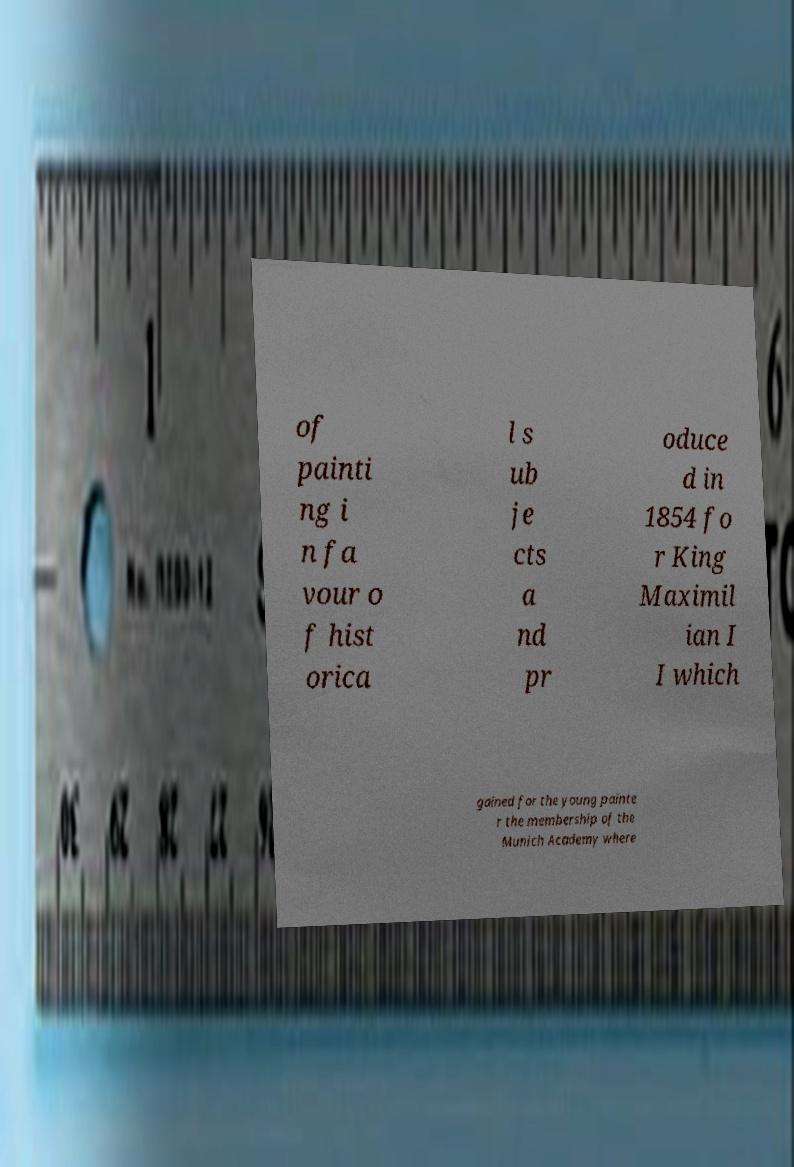There's text embedded in this image that I need extracted. Can you transcribe it verbatim? of painti ng i n fa vour o f hist orica l s ub je cts a nd pr oduce d in 1854 fo r King Maximil ian I I which gained for the young painte r the membership of the Munich Academy where 